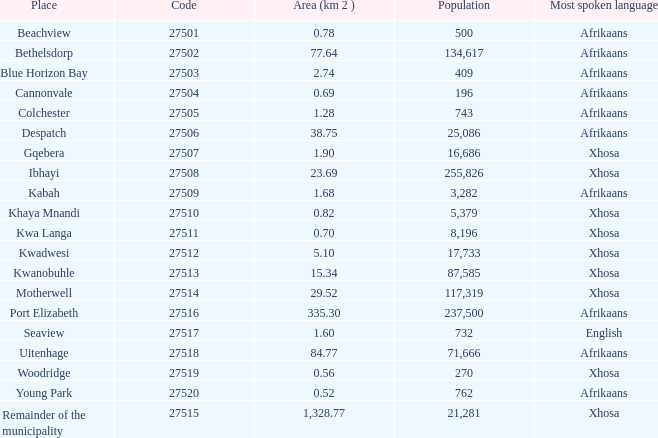What is the overall area in cannonvale where the population is less than 409? 1.0. 